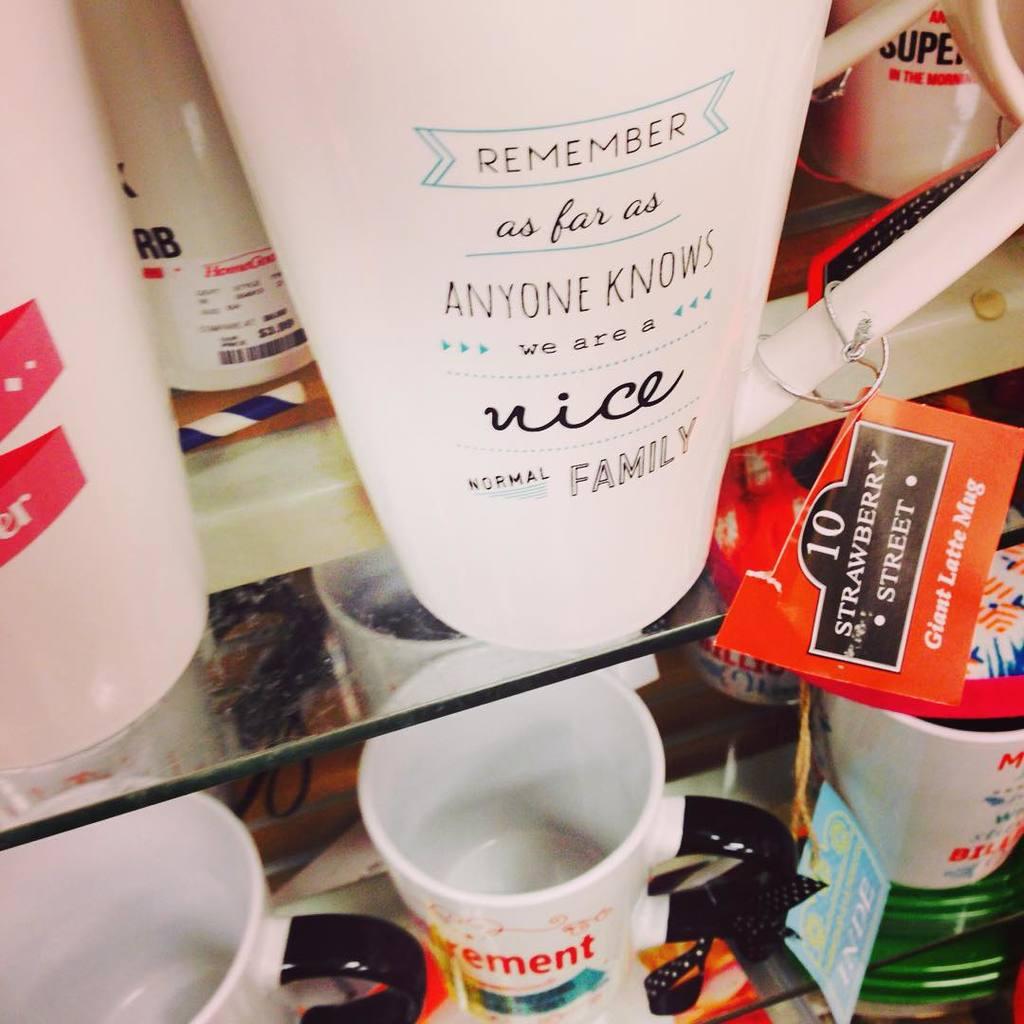What does this say to remember?
Ensure brevity in your answer.  We are a nice normal family. 